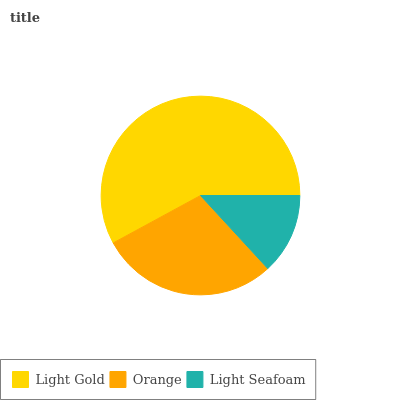Is Light Seafoam the minimum?
Answer yes or no. Yes. Is Light Gold the maximum?
Answer yes or no. Yes. Is Orange the minimum?
Answer yes or no. No. Is Orange the maximum?
Answer yes or no. No. Is Light Gold greater than Orange?
Answer yes or no. Yes. Is Orange less than Light Gold?
Answer yes or no. Yes. Is Orange greater than Light Gold?
Answer yes or no. No. Is Light Gold less than Orange?
Answer yes or no. No. Is Orange the high median?
Answer yes or no. Yes. Is Orange the low median?
Answer yes or no. Yes. Is Light Gold the high median?
Answer yes or no. No. Is Light Seafoam the low median?
Answer yes or no. No. 